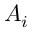<formula> <loc_0><loc_0><loc_500><loc_500>A _ { i }</formula> 